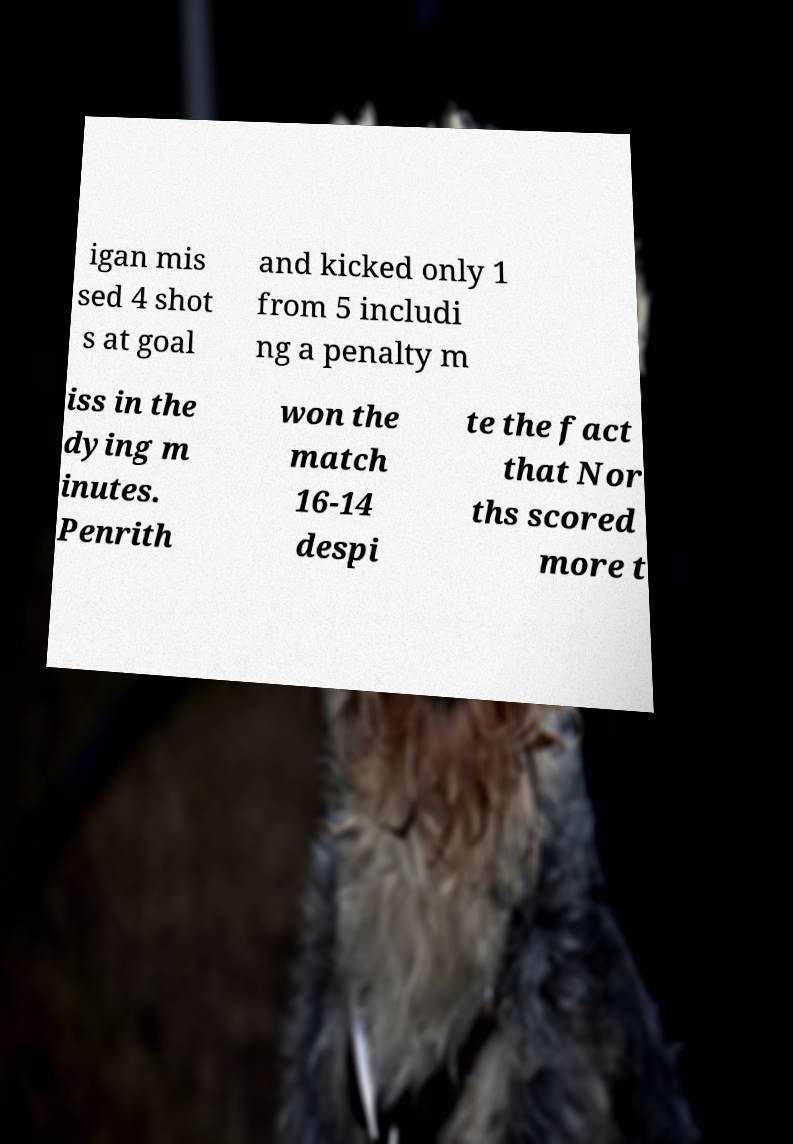Can you accurately transcribe the text from the provided image for me? igan mis sed 4 shot s at goal and kicked only 1 from 5 includi ng a penalty m iss in the dying m inutes. Penrith won the match 16-14 despi te the fact that Nor ths scored more t 